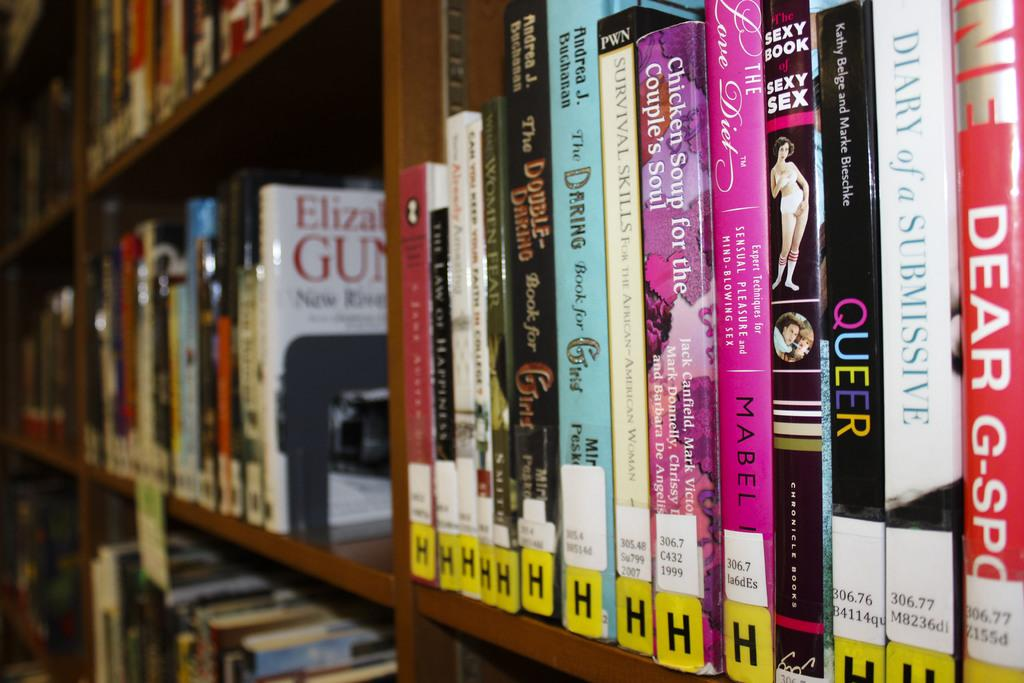<image>
Present a compact description of the photo's key features. Bookshelf with a row of books lined up beginning with the letter H. 